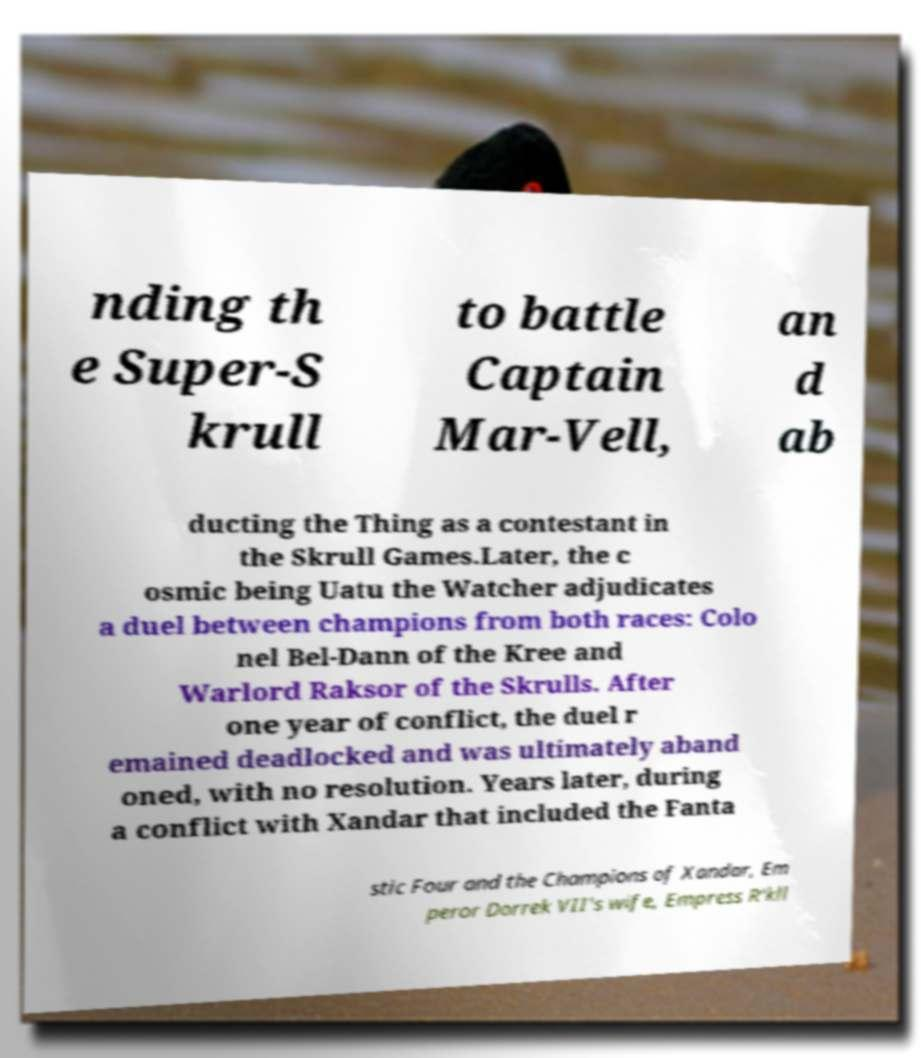What messages or text are displayed in this image? I need them in a readable, typed format. nding th e Super-S krull to battle Captain Mar-Vell, an d ab ducting the Thing as a contestant in the Skrull Games.Later, the c osmic being Uatu the Watcher adjudicates a duel between champions from both races: Colo nel Bel-Dann of the Kree and Warlord Raksor of the Skrulls. After one year of conflict, the duel r emained deadlocked and was ultimately aband oned, with no resolution. Years later, during a conflict with Xandar that included the Fanta stic Four and the Champions of Xandar, Em peror Dorrek VII's wife, Empress R'kll 